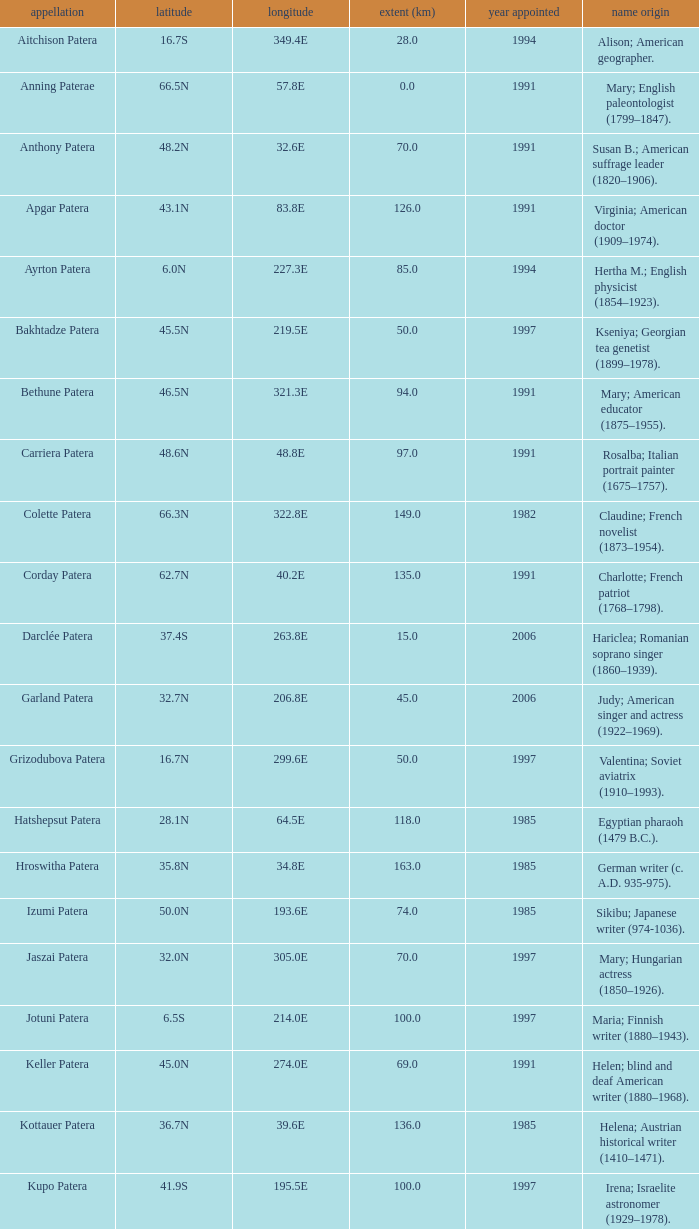What is the diameter in km of the feature named Colette Patera?  149.0. 